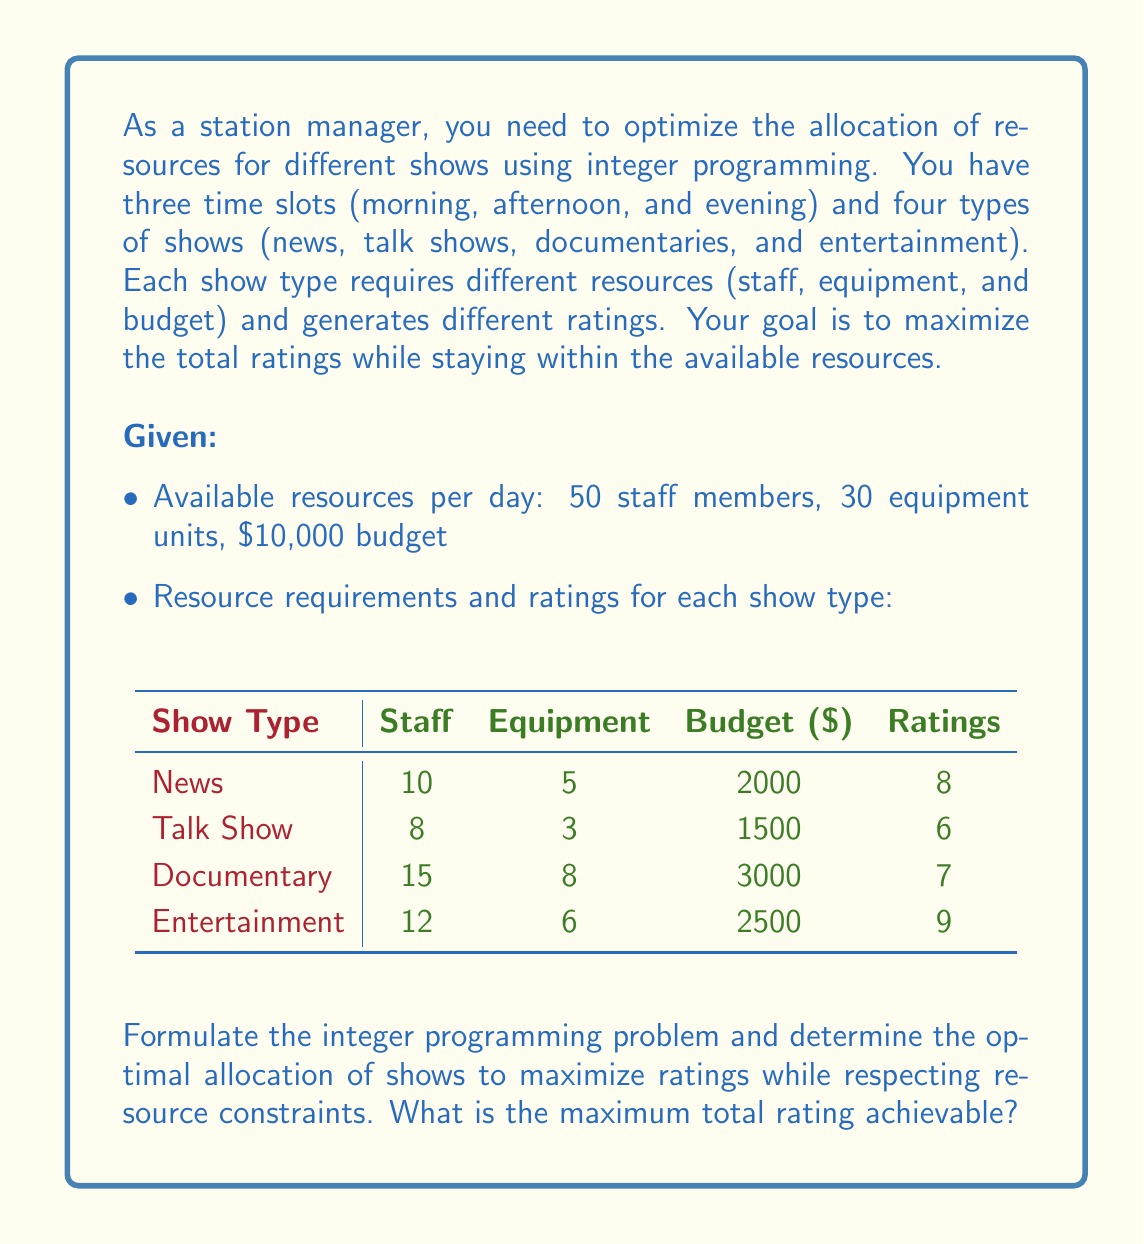Can you answer this question? To solve this problem, we need to formulate an integer programming model and then solve it. Let's break it down step by step:

1. Define decision variables:
   Let $x_{ij}$ be the number of shows of type $i$ in time slot $j$, where $i \in \{1,2,3,4\}$ represents the show types (news, talk show, documentary, entertainment) and $j \in \{1,2,3\}$ represents the time slots (morning, afternoon, evening).

2. Objective function:
   Maximize total ratings: 
   $$\text{Max } Z = 8x_{11} + 8x_{12} + 8x_{13} + 6x_{21} + 6x_{22} + 6x_{23} + 7x_{31} + 7x_{32} + 7x_{33} + 9x_{41} + 9x_{42} + 9x_{43}$$

3. Constraints:
   a) Resource constraints:
      Staff: $10x_{11} + 10x_{12} + 10x_{13} + 8x_{21} + 8x_{22} + 8x_{23} + 15x_{31} + 15x_{32} + 15x_{33} + 12x_{41} + 12x_{42} + 12x_{43} \leq 50$
      Equipment: $5x_{11} + 5x_{12} + 5x_{13} + 3x_{21} + 3x_{22} + 3x_{23} + 8x_{31} + 8x_{32} + 8x_{33} + 6x_{41} + 6x_{42} + 6x_{43} \leq 30$
      Budget: $2000x_{11} + 2000x_{12} + 2000x_{13} + 1500x_{21} + 1500x_{22} + 1500x_{23} + 3000x_{31} + 3000x_{32} + 3000x_{33} + 2500x_{41} + 2500x_{42} + 2500x_{43} \leq 10000$

   b) Time slot constraints (one show per time slot):
      $x_{11} + x_{21} + x_{31} + x_{41} = 1$
      $x_{12} + x_{22} + x_{32} + x_{42} = 1$
      $x_{13} + x_{23} + x_{33} + x_{43} = 1$

   c) Non-negativity and integer constraints:
      $x_{ij} \geq 0$ and integer for all $i$ and $j$

4. Solve the integer programming problem:
   Using an integer programming solver (e.g., branch and bound algorithm), we can find the optimal solution:

   $x_{11} = 1$ (News in the morning)
   $x_{42} = 1$ (Entertainment in the afternoon)
   $x_{43} = 1$ (Entertainment in the evening)
   All other $x_{ij} = 0$

5. Calculate the maximum total rating:
   $Z = 8(1) + 9(1) + 9(1) = 26$

Therefore, the maximum total rating achievable is 26.
Answer: The maximum total rating achievable is 26. 